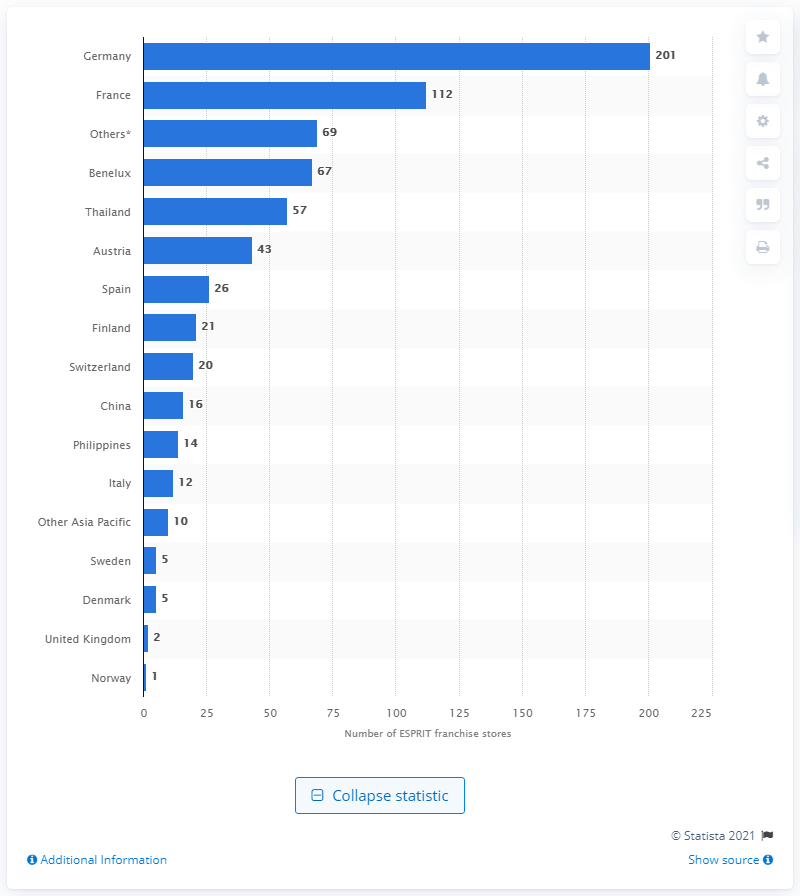Highlight a few significant elements in this photo. In 2019, the number of ESPRIT franchise stores in Germany was 2019. 